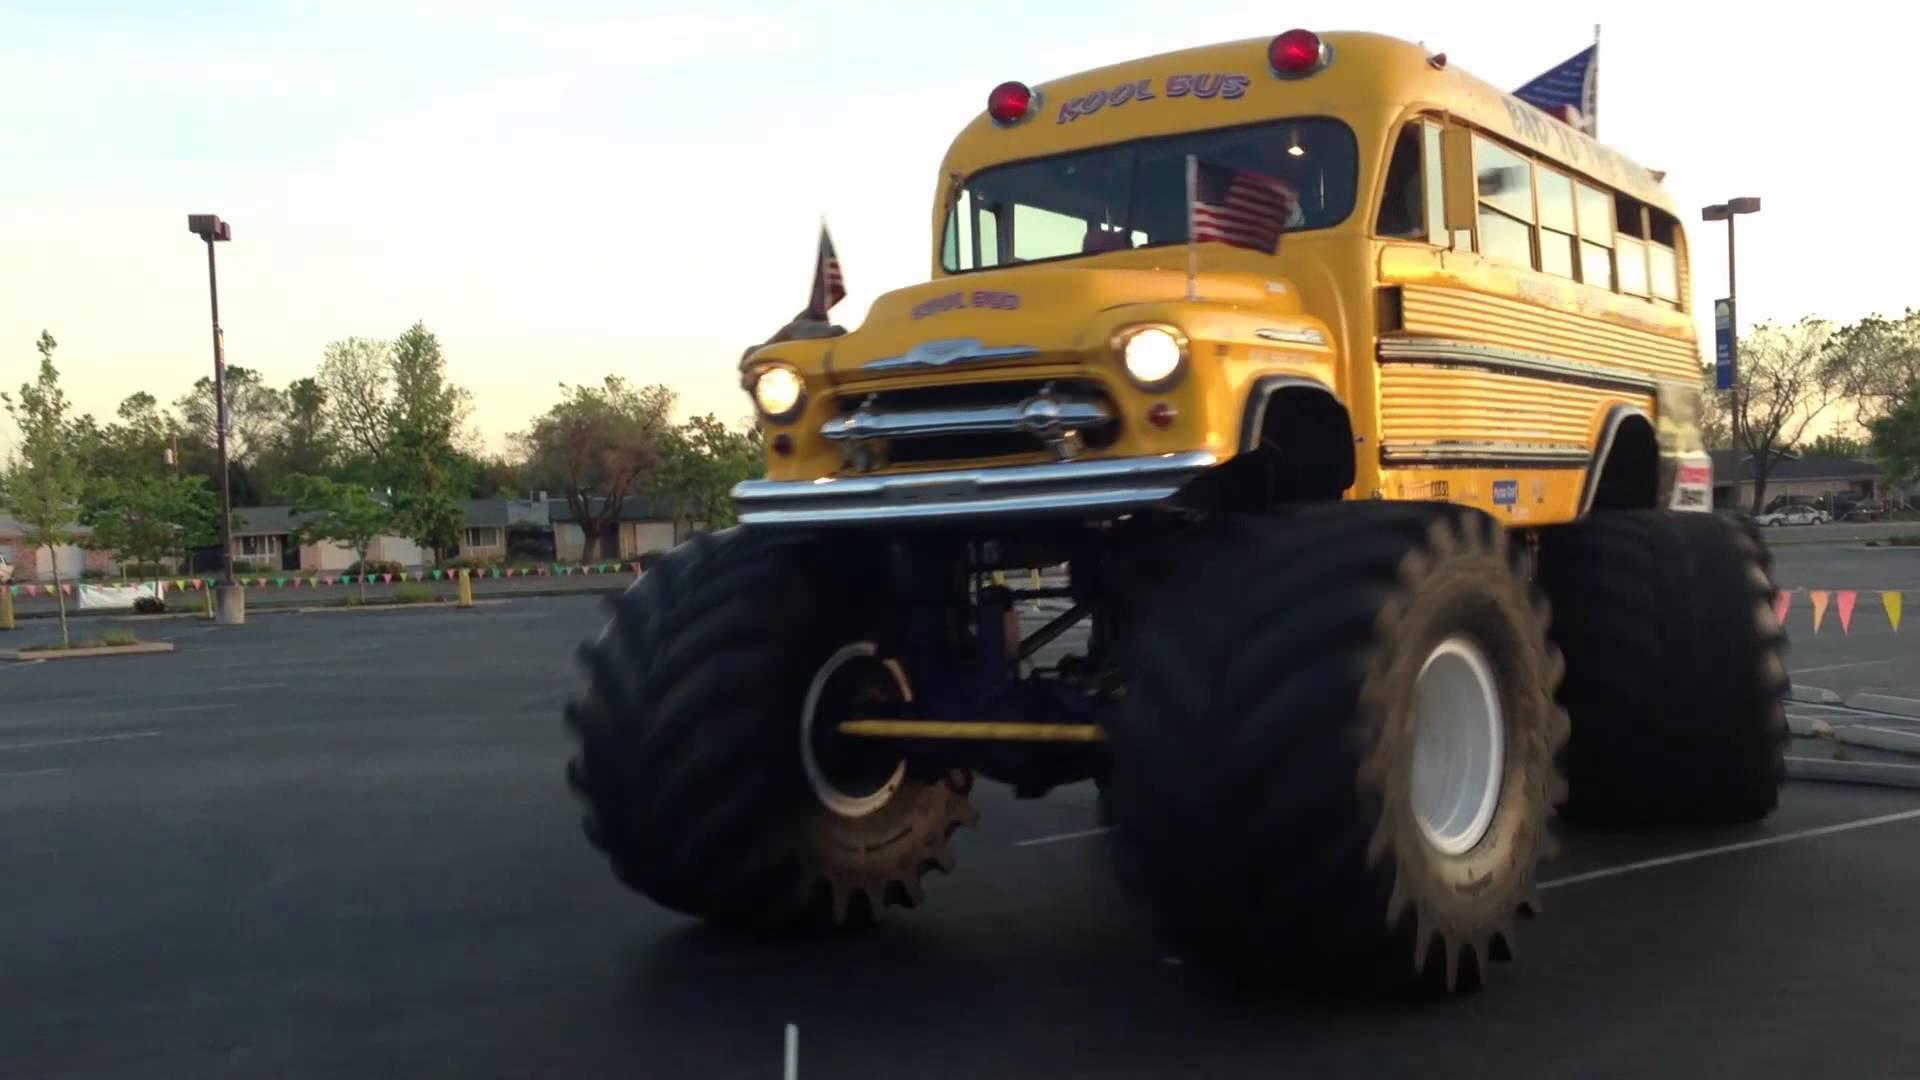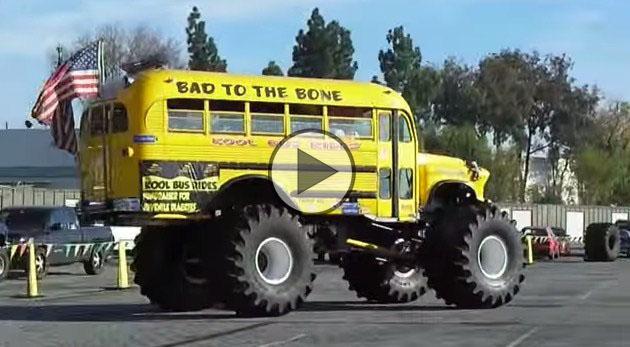The first image is the image on the left, the second image is the image on the right. Given the left and right images, does the statement "One image shows a big-wheeled yellow school bus with its front tires on top of a squashed white car." hold true? Answer yes or no. No. The first image is the image on the left, the second image is the image on the right. Given the left and right images, does the statement "In the left image a monster bus is driving over another vehicle." hold true? Answer yes or no. No. 